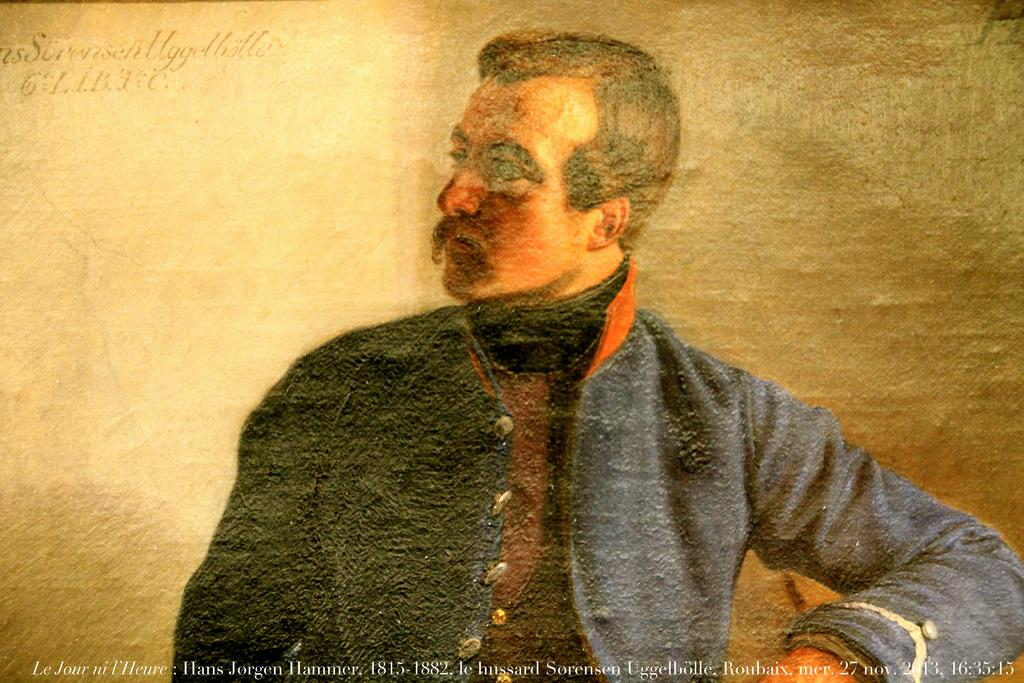What is depicted in the painting in the image? There is a painting of a man in the image. What else can be seen at the bottom of the image? There is text at the bottom of the image. How does the jellyfish compare to the man in the painting? There is no jellyfish present in the image, so it cannot be compared to the man in the painting. 